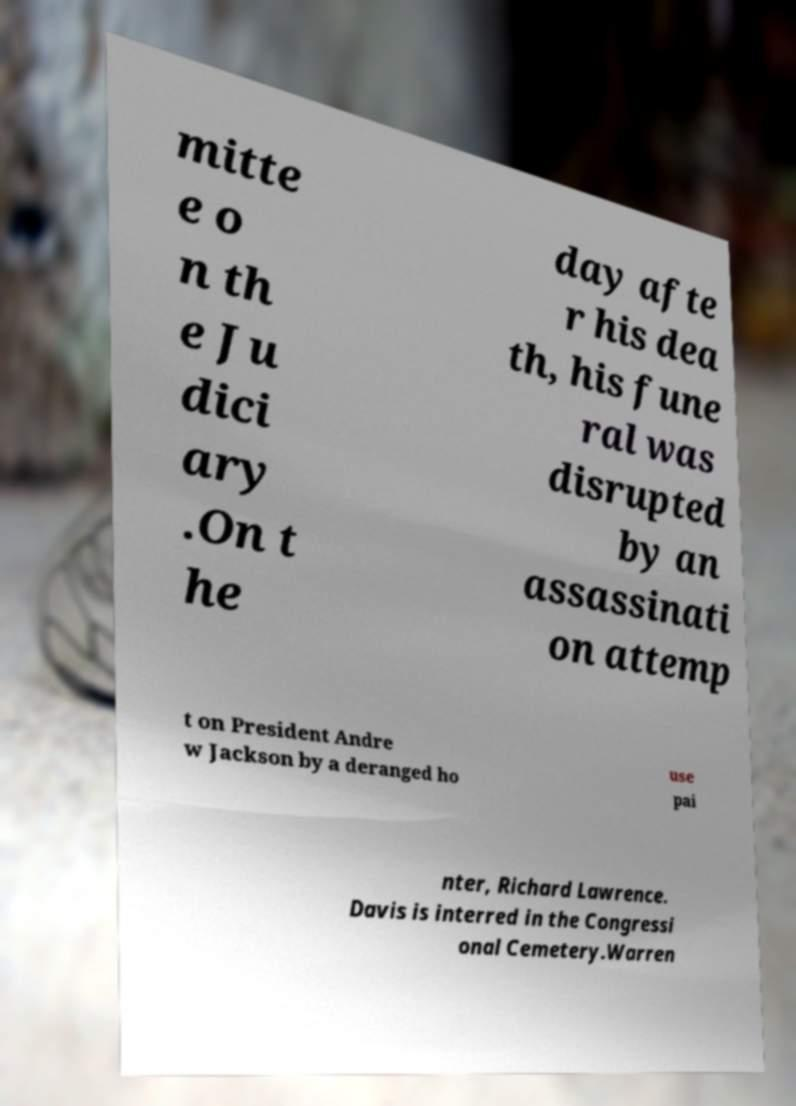For documentation purposes, I need the text within this image transcribed. Could you provide that? mitte e o n th e Ju dici ary .On t he day afte r his dea th, his fune ral was disrupted by an assassinati on attemp t on President Andre w Jackson by a deranged ho use pai nter, Richard Lawrence. Davis is interred in the Congressi onal Cemetery.Warren 